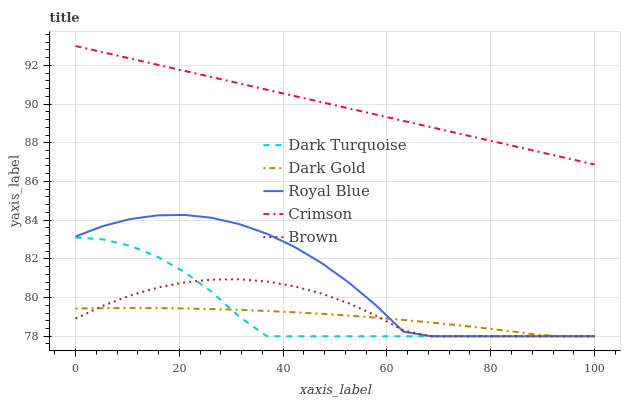Does Dark Gold have the minimum area under the curve?
Answer yes or no. Yes. Does Crimson have the maximum area under the curve?
Answer yes or no. Yes. Does Dark Turquoise have the minimum area under the curve?
Answer yes or no. No. Does Dark Turquoise have the maximum area under the curve?
Answer yes or no. No. Is Crimson the smoothest?
Answer yes or no. Yes. Is Royal Blue the roughest?
Answer yes or no. Yes. Is Dark Turquoise the smoothest?
Answer yes or no. No. Is Dark Turquoise the roughest?
Answer yes or no. No. Does Dark Turquoise have the lowest value?
Answer yes or no. Yes. Does Crimson have the highest value?
Answer yes or no. Yes. Does Dark Turquoise have the highest value?
Answer yes or no. No. Is Brown less than Crimson?
Answer yes or no. Yes. Is Crimson greater than Royal Blue?
Answer yes or no. Yes. Does Dark Turquoise intersect Royal Blue?
Answer yes or no. Yes. Is Dark Turquoise less than Royal Blue?
Answer yes or no. No. Is Dark Turquoise greater than Royal Blue?
Answer yes or no. No. Does Brown intersect Crimson?
Answer yes or no. No. 